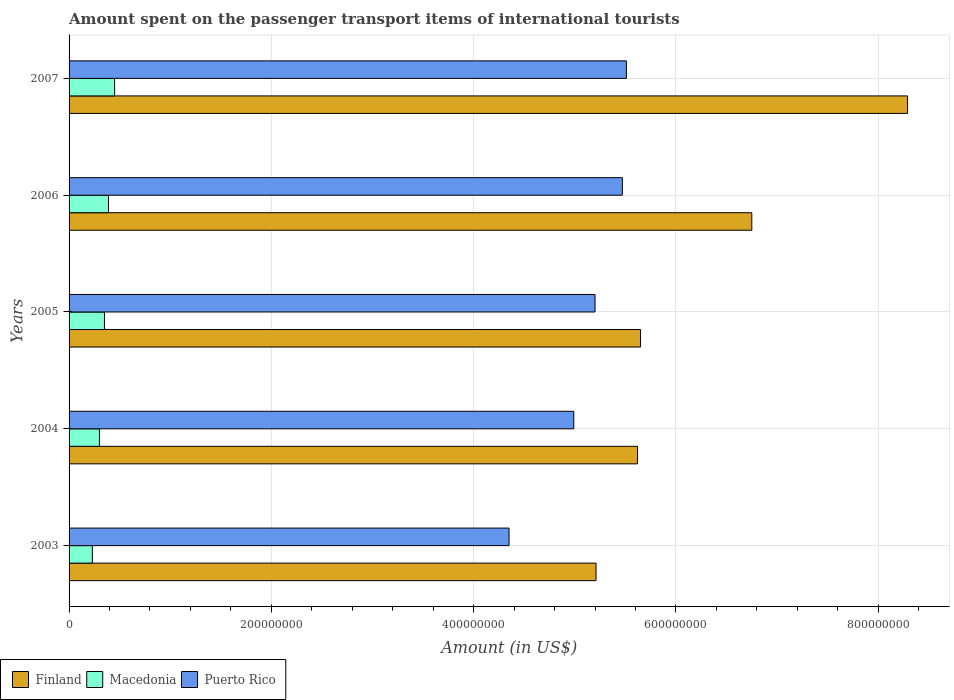How many different coloured bars are there?
Provide a short and direct response. 3. How many groups of bars are there?
Your answer should be compact. 5. How many bars are there on the 1st tick from the bottom?
Ensure brevity in your answer.  3. In how many cases, is the number of bars for a given year not equal to the number of legend labels?
Provide a short and direct response. 0. What is the amount spent on the passenger transport items of international tourists in Finland in 2005?
Your response must be concise. 5.65e+08. Across all years, what is the maximum amount spent on the passenger transport items of international tourists in Puerto Rico?
Ensure brevity in your answer.  5.51e+08. Across all years, what is the minimum amount spent on the passenger transport items of international tourists in Finland?
Ensure brevity in your answer.  5.21e+08. In which year was the amount spent on the passenger transport items of international tourists in Finland maximum?
Your answer should be very brief. 2007. In which year was the amount spent on the passenger transport items of international tourists in Macedonia minimum?
Make the answer very short. 2003. What is the total amount spent on the passenger transport items of international tourists in Finland in the graph?
Keep it short and to the point. 3.15e+09. What is the difference between the amount spent on the passenger transport items of international tourists in Macedonia in 2003 and that in 2004?
Your answer should be very brief. -7.00e+06. What is the difference between the amount spent on the passenger transport items of international tourists in Finland in 2006 and the amount spent on the passenger transport items of international tourists in Macedonia in 2003?
Your response must be concise. 6.52e+08. What is the average amount spent on the passenger transport items of international tourists in Macedonia per year?
Make the answer very short. 3.44e+07. In the year 2004, what is the difference between the amount spent on the passenger transport items of international tourists in Finland and amount spent on the passenger transport items of international tourists in Puerto Rico?
Your response must be concise. 6.30e+07. In how many years, is the amount spent on the passenger transport items of international tourists in Puerto Rico greater than 760000000 US$?
Make the answer very short. 0. What is the ratio of the amount spent on the passenger transport items of international tourists in Macedonia in 2003 to that in 2004?
Provide a short and direct response. 0.77. What is the difference between the highest and the second highest amount spent on the passenger transport items of international tourists in Finland?
Ensure brevity in your answer.  1.54e+08. What is the difference between the highest and the lowest amount spent on the passenger transport items of international tourists in Macedonia?
Offer a terse response. 2.20e+07. In how many years, is the amount spent on the passenger transport items of international tourists in Puerto Rico greater than the average amount spent on the passenger transport items of international tourists in Puerto Rico taken over all years?
Your answer should be very brief. 3. Is the sum of the amount spent on the passenger transport items of international tourists in Macedonia in 2004 and 2005 greater than the maximum amount spent on the passenger transport items of international tourists in Finland across all years?
Your answer should be very brief. No. What does the 1st bar from the top in 2003 represents?
Your response must be concise. Puerto Rico. What does the 2nd bar from the bottom in 2004 represents?
Your answer should be very brief. Macedonia. Is it the case that in every year, the sum of the amount spent on the passenger transport items of international tourists in Macedonia and amount spent on the passenger transport items of international tourists in Puerto Rico is greater than the amount spent on the passenger transport items of international tourists in Finland?
Ensure brevity in your answer.  No. How many bars are there?
Keep it short and to the point. 15. Are all the bars in the graph horizontal?
Offer a terse response. Yes. How many years are there in the graph?
Ensure brevity in your answer.  5. Does the graph contain any zero values?
Keep it short and to the point. No. How many legend labels are there?
Offer a very short reply. 3. What is the title of the graph?
Offer a terse response. Amount spent on the passenger transport items of international tourists. What is the label or title of the Y-axis?
Offer a terse response. Years. What is the Amount (in US$) of Finland in 2003?
Make the answer very short. 5.21e+08. What is the Amount (in US$) in Macedonia in 2003?
Offer a very short reply. 2.30e+07. What is the Amount (in US$) of Puerto Rico in 2003?
Your answer should be compact. 4.35e+08. What is the Amount (in US$) in Finland in 2004?
Keep it short and to the point. 5.62e+08. What is the Amount (in US$) in Macedonia in 2004?
Provide a succinct answer. 3.00e+07. What is the Amount (in US$) in Puerto Rico in 2004?
Provide a succinct answer. 4.99e+08. What is the Amount (in US$) in Finland in 2005?
Your response must be concise. 5.65e+08. What is the Amount (in US$) in Macedonia in 2005?
Ensure brevity in your answer.  3.50e+07. What is the Amount (in US$) of Puerto Rico in 2005?
Make the answer very short. 5.20e+08. What is the Amount (in US$) in Finland in 2006?
Ensure brevity in your answer.  6.75e+08. What is the Amount (in US$) in Macedonia in 2006?
Ensure brevity in your answer.  3.90e+07. What is the Amount (in US$) of Puerto Rico in 2006?
Ensure brevity in your answer.  5.47e+08. What is the Amount (in US$) in Finland in 2007?
Your answer should be very brief. 8.29e+08. What is the Amount (in US$) of Macedonia in 2007?
Offer a terse response. 4.50e+07. What is the Amount (in US$) in Puerto Rico in 2007?
Offer a terse response. 5.51e+08. Across all years, what is the maximum Amount (in US$) in Finland?
Offer a terse response. 8.29e+08. Across all years, what is the maximum Amount (in US$) of Macedonia?
Your answer should be compact. 4.50e+07. Across all years, what is the maximum Amount (in US$) of Puerto Rico?
Offer a very short reply. 5.51e+08. Across all years, what is the minimum Amount (in US$) of Finland?
Ensure brevity in your answer.  5.21e+08. Across all years, what is the minimum Amount (in US$) of Macedonia?
Ensure brevity in your answer.  2.30e+07. Across all years, what is the minimum Amount (in US$) of Puerto Rico?
Your answer should be compact. 4.35e+08. What is the total Amount (in US$) in Finland in the graph?
Ensure brevity in your answer.  3.15e+09. What is the total Amount (in US$) of Macedonia in the graph?
Provide a short and direct response. 1.72e+08. What is the total Amount (in US$) in Puerto Rico in the graph?
Your answer should be compact. 2.55e+09. What is the difference between the Amount (in US$) of Finland in 2003 and that in 2004?
Make the answer very short. -4.10e+07. What is the difference between the Amount (in US$) in Macedonia in 2003 and that in 2004?
Your answer should be compact. -7.00e+06. What is the difference between the Amount (in US$) of Puerto Rico in 2003 and that in 2004?
Give a very brief answer. -6.40e+07. What is the difference between the Amount (in US$) of Finland in 2003 and that in 2005?
Provide a short and direct response. -4.40e+07. What is the difference between the Amount (in US$) of Macedonia in 2003 and that in 2005?
Your response must be concise. -1.20e+07. What is the difference between the Amount (in US$) in Puerto Rico in 2003 and that in 2005?
Ensure brevity in your answer.  -8.50e+07. What is the difference between the Amount (in US$) in Finland in 2003 and that in 2006?
Your response must be concise. -1.54e+08. What is the difference between the Amount (in US$) of Macedonia in 2003 and that in 2006?
Keep it short and to the point. -1.60e+07. What is the difference between the Amount (in US$) in Puerto Rico in 2003 and that in 2006?
Give a very brief answer. -1.12e+08. What is the difference between the Amount (in US$) of Finland in 2003 and that in 2007?
Your answer should be very brief. -3.08e+08. What is the difference between the Amount (in US$) in Macedonia in 2003 and that in 2007?
Make the answer very short. -2.20e+07. What is the difference between the Amount (in US$) of Puerto Rico in 2003 and that in 2007?
Keep it short and to the point. -1.16e+08. What is the difference between the Amount (in US$) in Finland in 2004 and that in 2005?
Offer a terse response. -3.00e+06. What is the difference between the Amount (in US$) of Macedonia in 2004 and that in 2005?
Your response must be concise. -5.00e+06. What is the difference between the Amount (in US$) in Puerto Rico in 2004 and that in 2005?
Offer a terse response. -2.10e+07. What is the difference between the Amount (in US$) in Finland in 2004 and that in 2006?
Offer a terse response. -1.13e+08. What is the difference between the Amount (in US$) of Macedonia in 2004 and that in 2006?
Give a very brief answer. -9.00e+06. What is the difference between the Amount (in US$) in Puerto Rico in 2004 and that in 2006?
Give a very brief answer. -4.80e+07. What is the difference between the Amount (in US$) of Finland in 2004 and that in 2007?
Ensure brevity in your answer.  -2.67e+08. What is the difference between the Amount (in US$) of Macedonia in 2004 and that in 2007?
Ensure brevity in your answer.  -1.50e+07. What is the difference between the Amount (in US$) of Puerto Rico in 2004 and that in 2007?
Your response must be concise. -5.20e+07. What is the difference between the Amount (in US$) in Finland in 2005 and that in 2006?
Your answer should be very brief. -1.10e+08. What is the difference between the Amount (in US$) in Puerto Rico in 2005 and that in 2006?
Keep it short and to the point. -2.70e+07. What is the difference between the Amount (in US$) of Finland in 2005 and that in 2007?
Make the answer very short. -2.64e+08. What is the difference between the Amount (in US$) in Macedonia in 2005 and that in 2007?
Offer a very short reply. -1.00e+07. What is the difference between the Amount (in US$) of Puerto Rico in 2005 and that in 2007?
Your response must be concise. -3.10e+07. What is the difference between the Amount (in US$) of Finland in 2006 and that in 2007?
Offer a very short reply. -1.54e+08. What is the difference between the Amount (in US$) of Macedonia in 2006 and that in 2007?
Give a very brief answer. -6.00e+06. What is the difference between the Amount (in US$) in Puerto Rico in 2006 and that in 2007?
Provide a short and direct response. -4.00e+06. What is the difference between the Amount (in US$) in Finland in 2003 and the Amount (in US$) in Macedonia in 2004?
Your answer should be very brief. 4.91e+08. What is the difference between the Amount (in US$) in Finland in 2003 and the Amount (in US$) in Puerto Rico in 2004?
Ensure brevity in your answer.  2.20e+07. What is the difference between the Amount (in US$) of Macedonia in 2003 and the Amount (in US$) of Puerto Rico in 2004?
Offer a very short reply. -4.76e+08. What is the difference between the Amount (in US$) of Finland in 2003 and the Amount (in US$) of Macedonia in 2005?
Provide a succinct answer. 4.86e+08. What is the difference between the Amount (in US$) in Finland in 2003 and the Amount (in US$) in Puerto Rico in 2005?
Your response must be concise. 1.00e+06. What is the difference between the Amount (in US$) in Macedonia in 2003 and the Amount (in US$) in Puerto Rico in 2005?
Offer a terse response. -4.97e+08. What is the difference between the Amount (in US$) in Finland in 2003 and the Amount (in US$) in Macedonia in 2006?
Provide a short and direct response. 4.82e+08. What is the difference between the Amount (in US$) in Finland in 2003 and the Amount (in US$) in Puerto Rico in 2006?
Your answer should be very brief. -2.60e+07. What is the difference between the Amount (in US$) in Macedonia in 2003 and the Amount (in US$) in Puerto Rico in 2006?
Make the answer very short. -5.24e+08. What is the difference between the Amount (in US$) of Finland in 2003 and the Amount (in US$) of Macedonia in 2007?
Offer a very short reply. 4.76e+08. What is the difference between the Amount (in US$) in Finland in 2003 and the Amount (in US$) in Puerto Rico in 2007?
Your response must be concise. -3.00e+07. What is the difference between the Amount (in US$) in Macedonia in 2003 and the Amount (in US$) in Puerto Rico in 2007?
Keep it short and to the point. -5.28e+08. What is the difference between the Amount (in US$) of Finland in 2004 and the Amount (in US$) of Macedonia in 2005?
Make the answer very short. 5.27e+08. What is the difference between the Amount (in US$) of Finland in 2004 and the Amount (in US$) of Puerto Rico in 2005?
Your answer should be very brief. 4.20e+07. What is the difference between the Amount (in US$) in Macedonia in 2004 and the Amount (in US$) in Puerto Rico in 2005?
Your answer should be very brief. -4.90e+08. What is the difference between the Amount (in US$) of Finland in 2004 and the Amount (in US$) of Macedonia in 2006?
Your answer should be compact. 5.23e+08. What is the difference between the Amount (in US$) in Finland in 2004 and the Amount (in US$) in Puerto Rico in 2006?
Ensure brevity in your answer.  1.50e+07. What is the difference between the Amount (in US$) of Macedonia in 2004 and the Amount (in US$) of Puerto Rico in 2006?
Offer a very short reply. -5.17e+08. What is the difference between the Amount (in US$) in Finland in 2004 and the Amount (in US$) in Macedonia in 2007?
Offer a very short reply. 5.17e+08. What is the difference between the Amount (in US$) of Finland in 2004 and the Amount (in US$) of Puerto Rico in 2007?
Make the answer very short. 1.10e+07. What is the difference between the Amount (in US$) in Macedonia in 2004 and the Amount (in US$) in Puerto Rico in 2007?
Your answer should be compact. -5.21e+08. What is the difference between the Amount (in US$) of Finland in 2005 and the Amount (in US$) of Macedonia in 2006?
Offer a terse response. 5.26e+08. What is the difference between the Amount (in US$) in Finland in 2005 and the Amount (in US$) in Puerto Rico in 2006?
Keep it short and to the point. 1.80e+07. What is the difference between the Amount (in US$) in Macedonia in 2005 and the Amount (in US$) in Puerto Rico in 2006?
Offer a terse response. -5.12e+08. What is the difference between the Amount (in US$) in Finland in 2005 and the Amount (in US$) in Macedonia in 2007?
Offer a very short reply. 5.20e+08. What is the difference between the Amount (in US$) of Finland in 2005 and the Amount (in US$) of Puerto Rico in 2007?
Provide a short and direct response. 1.40e+07. What is the difference between the Amount (in US$) in Macedonia in 2005 and the Amount (in US$) in Puerto Rico in 2007?
Keep it short and to the point. -5.16e+08. What is the difference between the Amount (in US$) in Finland in 2006 and the Amount (in US$) in Macedonia in 2007?
Offer a terse response. 6.30e+08. What is the difference between the Amount (in US$) in Finland in 2006 and the Amount (in US$) in Puerto Rico in 2007?
Provide a short and direct response. 1.24e+08. What is the difference between the Amount (in US$) in Macedonia in 2006 and the Amount (in US$) in Puerto Rico in 2007?
Provide a short and direct response. -5.12e+08. What is the average Amount (in US$) of Finland per year?
Ensure brevity in your answer.  6.30e+08. What is the average Amount (in US$) in Macedonia per year?
Offer a terse response. 3.44e+07. What is the average Amount (in US$) in Puerto Rico per year?
Provide a short and direct response. 5.10e+08. In the year 2003, what is the difference between the Amount (in US$) of Finland and Amount (in US$) of Macedonia?
Provide a short and direct response. 4.98e+08. In the year 2003, what is the difference between the Amount (in US$) in Finland and Amount (in US$) in Puerto Rico?
Your answer should be compact. 8.60e+07. In the year 2003, what is the difference between the Amount (in US$) in Macedonia and Amount (in US$) in Puerto Rico?
Ensure brevity in your answer.  -4.12e+08. In the year 2004, what is the difference between the Amount (in US$) in Finland and Amount (in US$) in Macedonia?
Provide a succinct answer. 5.32e+08. In the year 2004, what is the difference between the Amount (in US$) of Finland and Amount (in US$) of Puerto Rico?
Offer a very short reply. 6.30e+07. In the year 2004, what is the difference between the Amount (in US$) of Macedonia and Amount (in US$) of Puerto Rico?
Make the answer very short. -4.69e+08. In the year 2005, what is the difference between the Amount (in US$) in Finland and Amount (in US$) in Macedonia?
Provide a short and direct response. 5.30e+08. In the year 2005, what is the difference between the Amount (in US$) of Finland and Amount (in US$) of Puerto Rico?
Your answer should be compact. 4.50e+07. In the year 2005, what is the difference between the Amount (in US$) in Macedonia and Amount (in US$) in Puerto Rico?
Your answer should be very brief. -4.85e+08. In the year 2006, what is the difference between the Amount (in US$) in Finland and Amount (in US$) in Macedonia?
Ensure brevity in your answer.  6.36e+08. In the year 2006, what is the difference between the Amount (in US$) in Finland and Amount (in US$) in Puerto Rico?
Offer a very short reply. 1.28e+08. In the year 2006, what is the difference between the Amount (in US$) in Macedonia and Amount (in US$) in Puerto Rico?
Provide a short and direct response. -5.08e+08. In the year 2007, what is the difference between the Amount (in US$) in Finland and Amount (in US$) in Macedonia?
Your answer should be very brief. 7.84e+08. In the year 2007, what is the difference between the Amount (in US$) in Finland and Amount (in US$) in Puerto Rico?
Your response must be concise. 2.78e+08. In the year 2007, what is the difference between the Amount (in US$) in Macedonia and Amount (in US$) in Puerto Rico?
Your answer should be very brief. -5.06e+08. What is the ratio of the Amount (in US$) of Finland in 2003 to that in 2004?
Keep it short and to the point. 0.93. What is the ratio of the Amount (in US$) of Macedonia in 2003 to that in 2004?
Provide a succinct answer. 0.77. What is the ratio of the Amount (in US$) in Puerto Rico in 2003 to that in 2004?
Ensure brevity in your answer.  0.87. What is the ratio of the Amount (in US$) of Finland in 2003 to that in 2005?
Give a very brief answer. 0.92. What is the ratio of the Amount (in US$) of Macedonia in 2003 to that in 2005?
Keep it short and to the point. 0.66. What is the ratio of the Amount (in US$) in Puerto Rico in 2003 to that in 2005?
Offer a terse response. 0.84. What is the ratio of the Amount (in US$) in Finland in 2003 to that in 2006?
Your answer should be compact. 0.77. What is the ratio of the Amount (in US$) of Macedonia in 2003 to that in 2006?
Give a very brief answer. 0.59. What is the ratio of the Amount (in US$) in Puerto Rico in 2003 to that in 2006?
Offer a very short reply. 0.8. What is the ratio of the Amount (in US$) of Finland in 2003 to that in 2007?
Offer a very short reply. 0.63. What is the ratio of the Amount (in US$) in Macedonia in 2003 to that in 2007?
Offer a terse response. 0.51. What is the ratio of the Amount (in US$) in Puerto Rico in 2003 to that in 2007?
Make the answer very short. 0.79. What is the ratio of the Amount (in US$) in Finland in 2004 to that in 2005?
Offer a terse response. 0.99. What is the ratio of the Amount (in US$) of Puerto Rico in 2004 to that in 2005?
Offer a terse response. 0.96. What is the ratio of the Amount (in US$) of Finland in 2004 to that in 2006?
Keep it short and to the point. 0.83. What is the ratio of the Amount (in US$) in Macedonia in 2004 to that in 2006?
Offer a terse response. 0.77. What is the ratio of the Amount (in US$) of Puerto Rico in 2004 to that in 2006?
Your answer should be very brief. 0.91. What is the ratio of the Amount (in US$) in Finland in 2004 to that in 2007?
Give a very brief answer. 0.68. What is the ratio of the Amount (in US$) in Macedonia in 2004 to that in 2007?
Offer a very short reply. 0.67. What is the ratio of the Amount (in US$) of Puerto Rico in 2004 to that in 2007?
Provide a short and direct response. 0.91. What is the ratio of the Amount (in US$) in Finland in 2005 to that in 2006?
Offer a very short reply. 0.84. What is the ratio of the Amount (in US$) in Macedonia in 2005 to that in 2006?
Provide a short and direct response. 0.9. What is the ratio of the Amount (in US$) in Puerto Rico in 2005 to that in 2006?
Your answer should be very brief. 0.95. What is the ratio of the Amount (in US$) of Finland in 2005 to that in 2007?
Give a very brief answer. 0.68. What is the ratio of the Amount (in US$) in Puerto Rico in 2005 to that in 2007?
Offer a very short reply. 0.94. What is the ratio of the Amount (in US$) of Finland in 2006 to that in 2007?
Give a very brief answer. 0.81. What is the ratio of the Amount (in US$) in Macedonia in 2006 to that in 2007?
Make the answer very short. 0.87. What is the ratio of the Amount (in US$) of Puerto Rico in 2006 to that in 2007?
Make the answer very short. 0.99. What is the difference between the highest and the second highest Amount (in US$) in Finland?
Provide a succinct answer. 1.54e+08. What is the difference between the highest and the lowest Amount (in US$) of Finland?
Your answer should be very brief. 3.08e+08. What is the difference between the highest and the lowest Amount (in US$) in Macedonia?
Offer a very short reply. 2.20e+07. What is the difference between the highest and the lowest Amount (in US$) in Puerto Rico?
Give a very brief answer. 1.16e+08. 